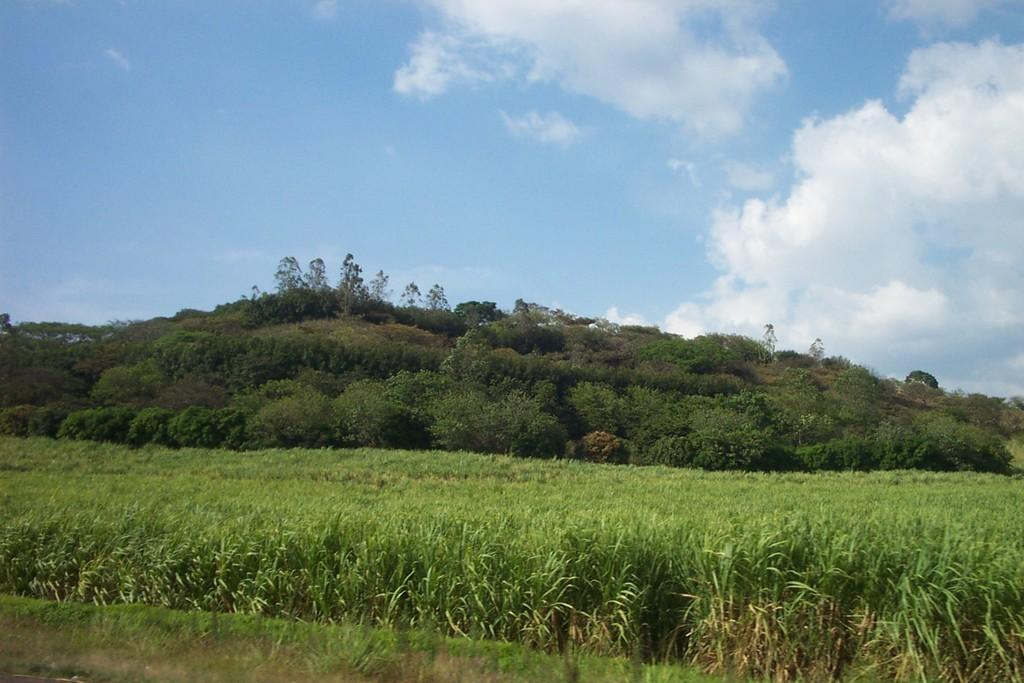What type of vegetation can be seen in the image? There are plants and trees in the image. What can be seen in the sky in the image? There are clouds visible in the image. What type of trip is the rat planning to take in the image? There is no rat present in the image, so it is not possible to answer that question. 